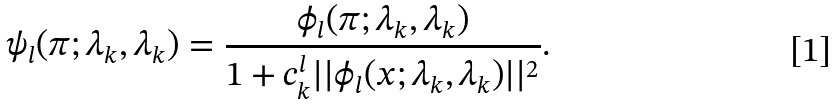Convert formula to latex. <formula><loc_0><loc_0><loc_500><loc_500>\psi _ { l } ( \pi ; \lambda _ { k } , \lambda _ { k } ) = \frac { \phi _ { l } ( \pi ; \lambda _ { k } , \lambda _ { k } ) } { 1 + c _ { k } ^ { l } | | \phi _ { l } ( x ; \lambda _ { k } , \lambda _ { k } ) | | ^ { 2 } } .</formula> 